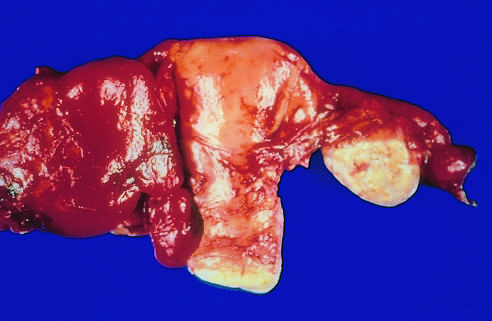re the tube and ovary to the left of the uterus totally obscured by a hemorrhagic inflammatory mass?
Answer the question using a single word or phrase. Yes 